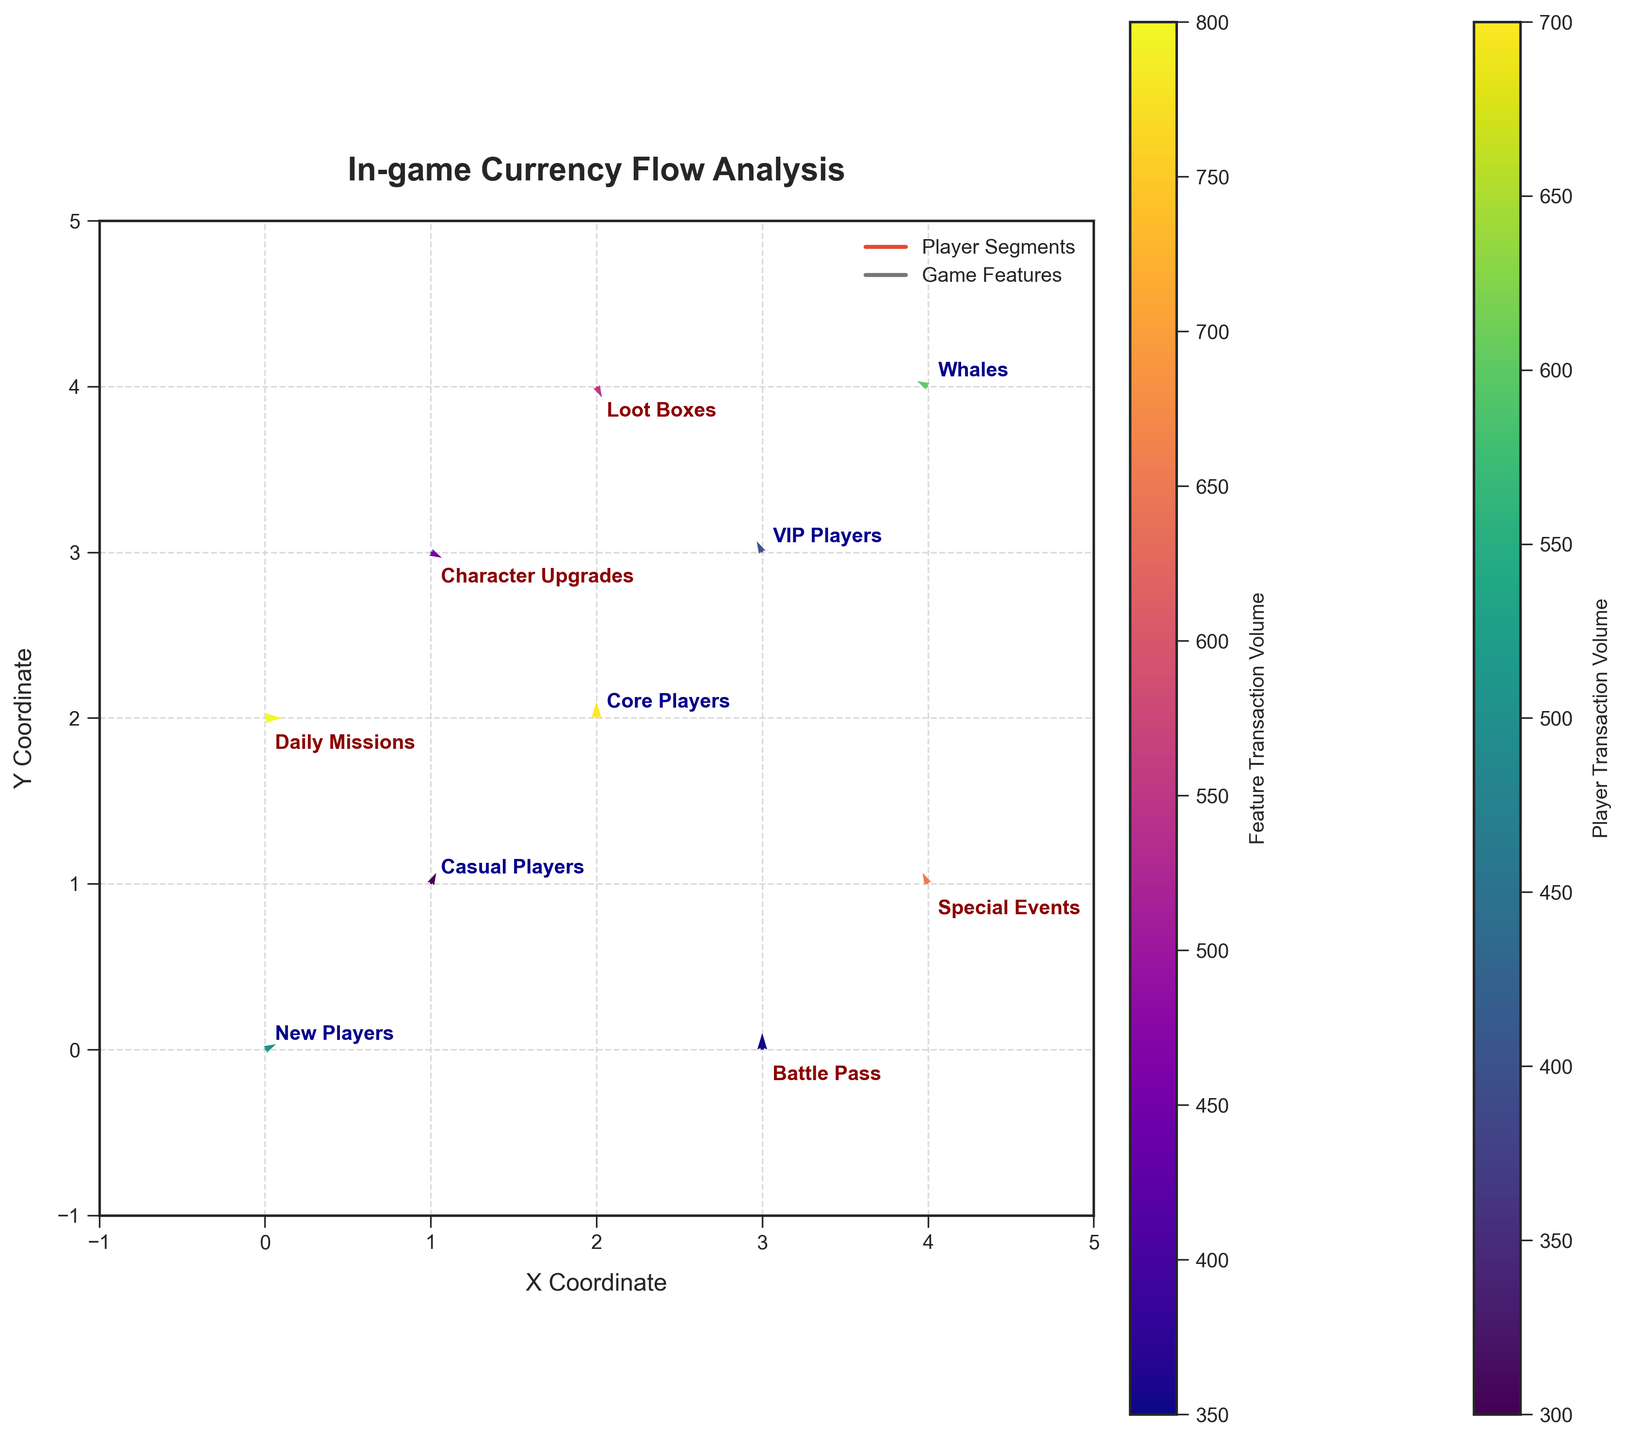What is the title of the plot? The title is written in bold at the top of the plot. By reading the text, we can determine the title of the plot.
Answer: In-game Currency Flow Analysis How many player segments are indicated in the plot? We can count the number of unique labels in blue that denote player segments.
Answer: 5 Which player segment has the highest transaction magnitude? By observing the color intensity for player segments indicated by the color bar labeled 'Player Transaction Volume', we can identify the player segment with the highest magnitude.
Answer: Core Players What is the direction of the quiver representing "Daily Missions"? We can determine the direction by checking the arrow attached to the "Daily Missions" segment, which remains horizontal due to u=3 and v=0.
Answer: Horizontal How does the transaction flow for "VIP Players" compare to "Casual Players"? By looking at the arrows linked with each segment, we see that "VIP Players" have a leftward flow (u=-1) while "Casual Players" have a rightward upward flow (u=1, v=2).
Answer: VIP Players: Leftward, Casual Players: Rightward upward Which game feature has the strongest currency inflow based on the magnitude? By comparing the intensities of game feature colors using the 'Feature Transaction Volume' color bar, the segment with the lightest intensity can be identified.
Answer: Daily Missions What is the overall direction trend for the "Whales" segment? By examining the arrow associated with the "Whales" player segment, we see that it flows leftward and slightly upward due to u=-2 and v=1.
Answer: Leftward and slightly upward Which player segment has the smallest transaction volume? By evaluating the weakest color intensity for player segments in the 'Player Transaction Volume' color bar, we can identify the segment with the lowest magnitude.
Answer: Casual Players Explain the relationship between "Special Events" and the flow direction. Observing the arrow near "Special Events", which is downward and rightward (u=-1, v=2), indicates the flow direction for this feature.
Answer: Downward rightward Which player segment has the largest vertical component in their currency flow? Analyzing the vertical components (v values) of arrows shows "Core Players" with the highest v value of 3, leading to the largest vertical component.
Answer: Core Players 